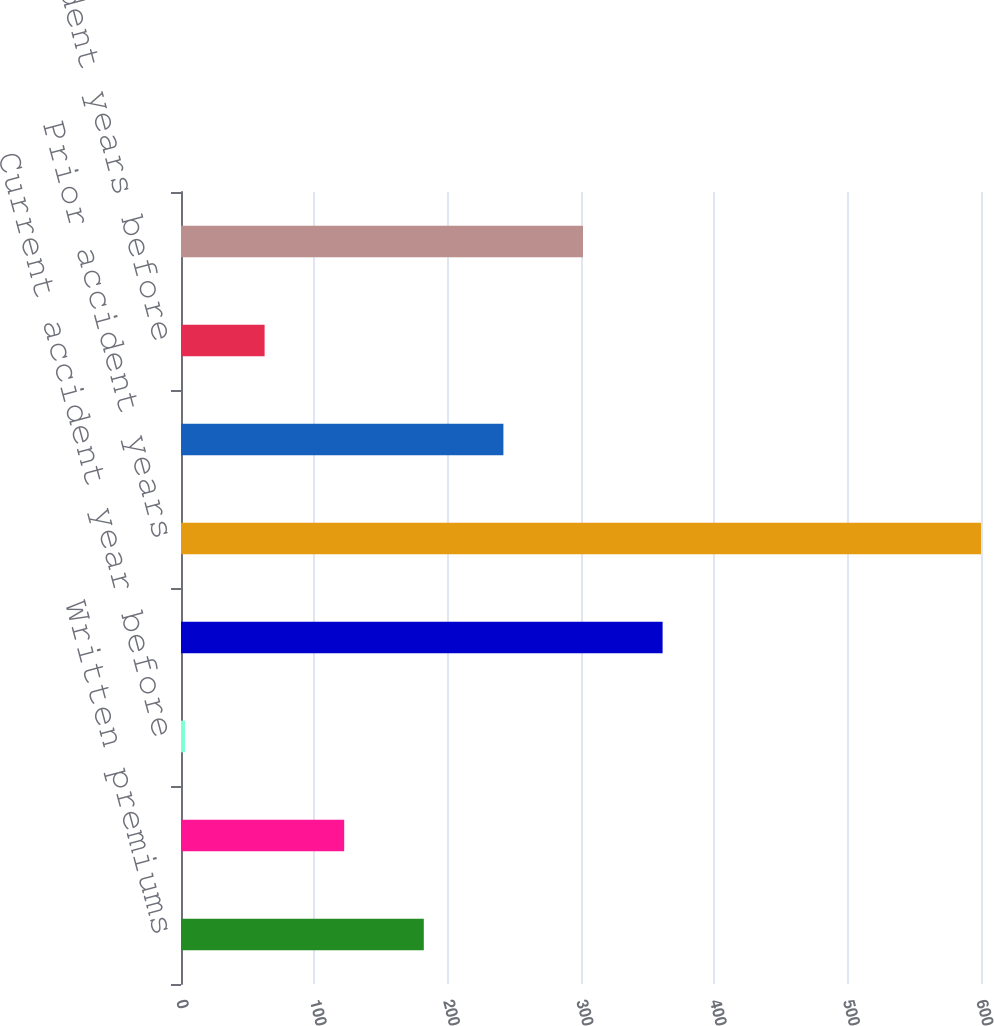<chart> <loc_0><loc_0><loc_500><loc_500><bar_chart><fcel>Written premiums<fcel>Earned premiums<fcel>Current accident year before<fcel>Current accident year<fcel>Prior accident years<fcel>Total loss and loss expenses<fcel>Prior accident years before<fcel>Total loss and loss expense<nl><fcel>182.1<fcel>122.4<fcel>3<fcel>361.2<fcel>600<fcel>241.8<fcel>62.7<fcel>301.5<nl></chart> 